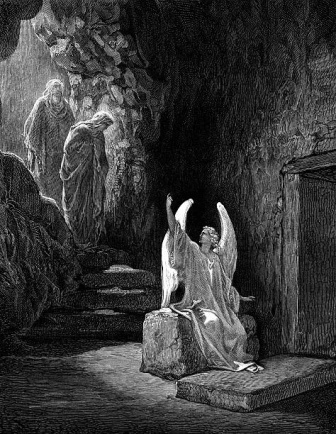What could be the significance of the angel kneeling and spreading its wings in this setting? The angel's pose, kneeling with wings spread wide, could symbolize a moment of divine intervention or reverence. This posture might signify humility, prayer, or an act of protection, particularly in the solemn and isolated cave setting. The halo suggests a connection to the divine, indicating that this moment is of spiritual significance. The cave could represent a place of refuge, introspection, or a mystical location where celestial beings make contact with the earthly realm. Why do you think the two figures have their heads covered? The covered heads of the two figures add an element of secrecy or reverence to the scene. This could imply that they are either engaging in a ritual, paying respect, or that their identities are purposefully concealed to maintain an air of mystery. In many traditions, covered heads can signify humility, penitence, or participation in a sacred ceremony, aligning with the divine theme suggested by the angel. 